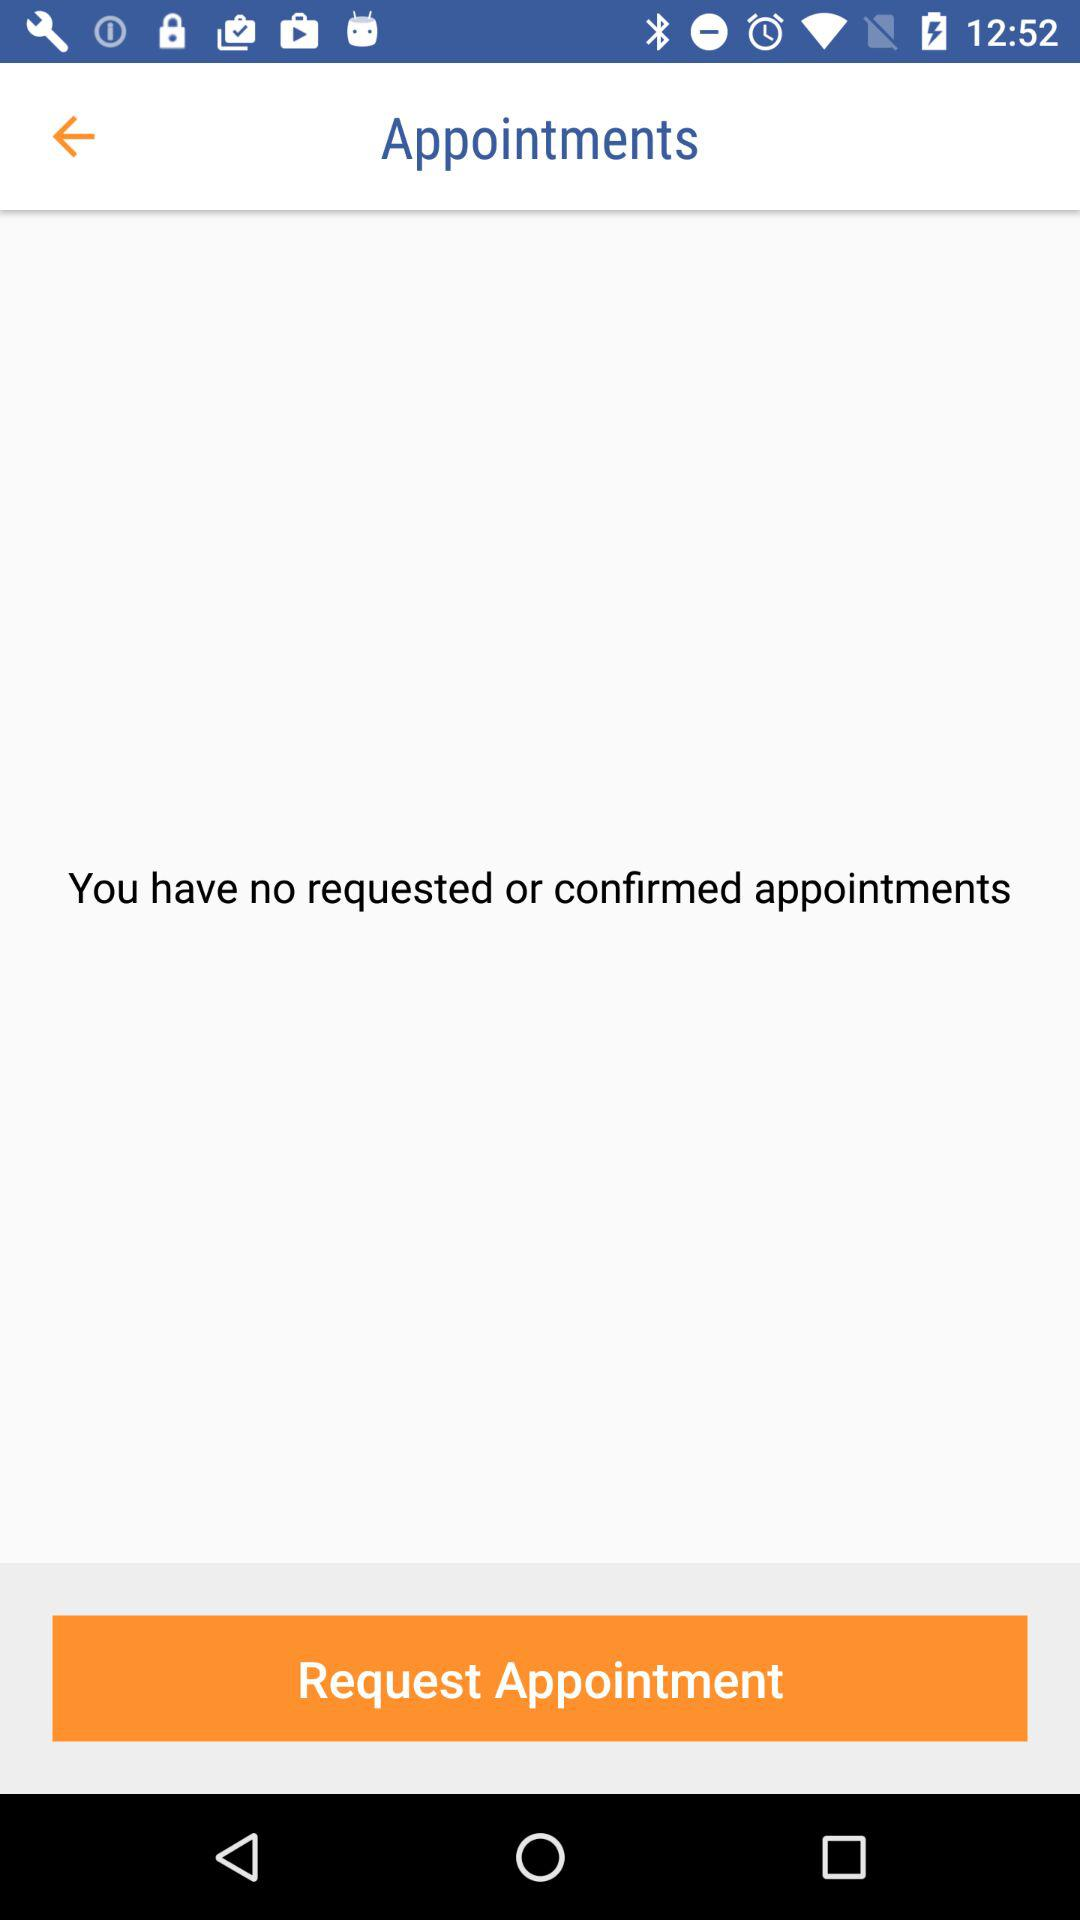What is the total number of requested or confirmed appointments? You have no requested or confirmed appointments. 